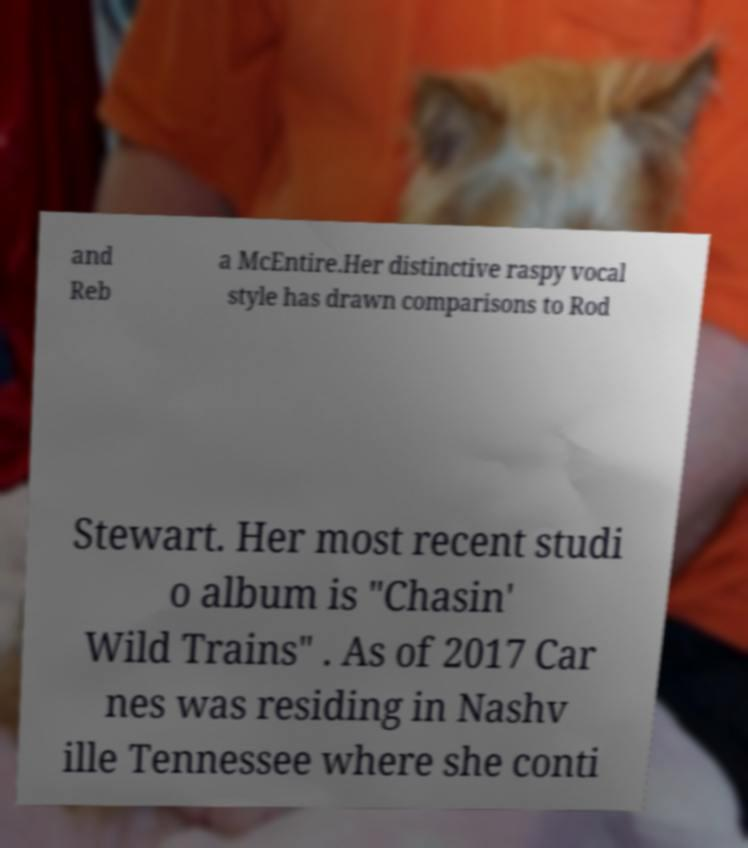Please identify and transcribe the text found in this image. and Reb a McEntire.Her distinctive raspy vocal style has drawn comparisons to Rod Stewart. Her most recent studi o album is "Chasin' Wild Trains" . As of 2017 Car nes was residing in Nashv ille Tennessee where she conti 